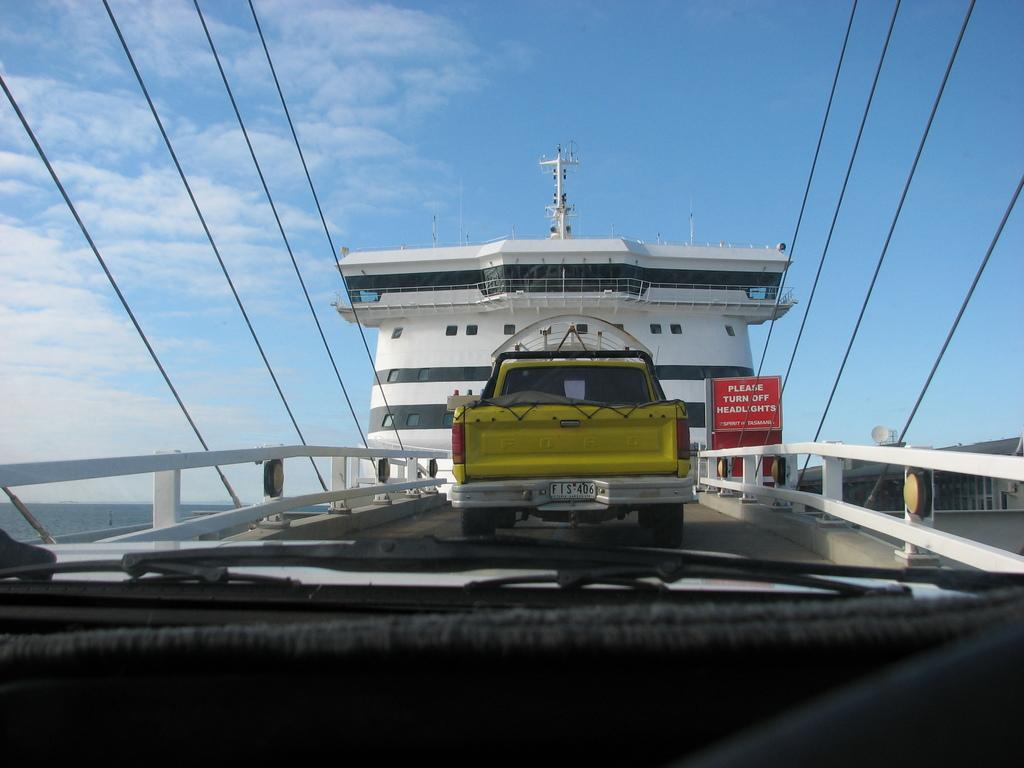What is happening on the bridge in the image? There are vehicles moving on a bridge in the image. What is the bridge built over? The bridge is constructed over the ocean. What else can be seen in the image besides the bridge and vehicles? There is a building visible in the image. How would you describe the weather based on the image? The sky is clear in the image, suggesting good weather. Can you see any friends or dinosaurs playing together on the bridge in the image? No, there are no friends or dinosaurs present in the image; it features vehicles moving on a bridge over the ocean. Are there any mice visible in the image? No, there are no mice present in the image. 